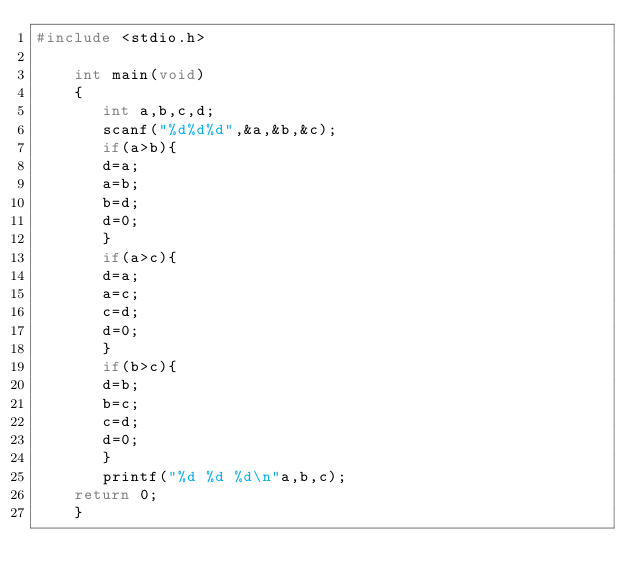Convert code to text. <code><loc_0><loc_0><loc_500><loc_500><_C_>#include <stdio.h>

    int main(void)
    {
       int a,b,c,d;
       scanf("%d%d%d",&a,&b,&c);
       if(a>b){
       d=a;
       a=b;
       b=d;
       d=0;
       } 
       if(a>c){
       d=a;
       a=c;
       c=d;
       d=0;
       }
       if(b>c){
       d=b;
       b=c;
       c=d;
       d=0;
       }
       printf("%d %d %d\n"a,b,c);
	return 0;
    }</code> 